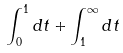Convert formula to latex. <formula><loc_0><loc_0><loc_500><loc_500>\int _ { 0 } ^ { 1 } d t + \int _ { 1 } ^ { \infty } d t</formula> 